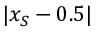Convert formula to latex. <formula><loc_0><loc_0><loc_500><loc_500>| x _ { S } - 0 . 5 |</formula> 